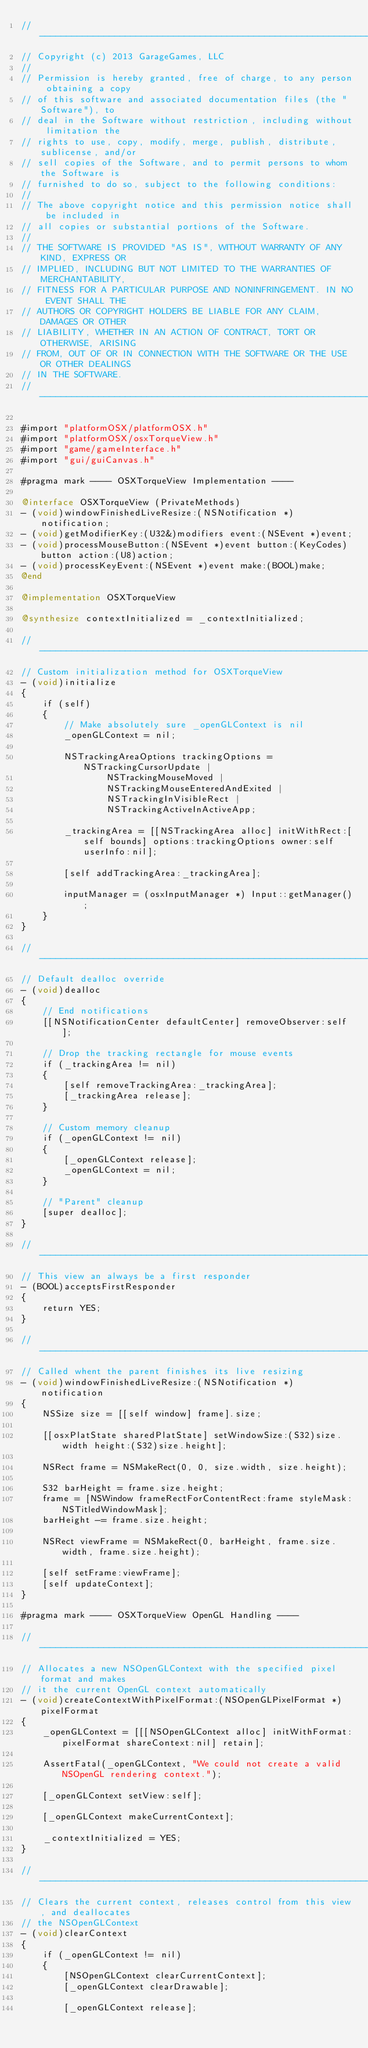Convert code to text. <code><loc_0><loc_0><loc_500><loc_500><_ObjectiveC_>//-----------------------------------------------------------------------------
// Copyright (c) 2013 GarageGames, LLC
//
// Permission is hereby granted, free of charge, to any person obtaining a copy
// of this software and associated documentation files (the "Software"), to
// deal in the Software without restriction, including without limitation the
// rights to use, copy, modify, merge, publish, distribute, sublicense, and/or
// sell copies of the Software, and to permit persons to whom the Software is
// furnished to do so, subject to the following conditions:
//
// The above copyright notice and this permission notice shall be included in
// all copies or substantial portions of the Software.
//
// THE SOFTWARE IS PROVIDED "AS IS", WITHOUT WARRANTY OF ANY KIND, EXPRESS OR
// IMPLIED, INCLUDING BUT NOT LIMITED TO THE WARRANTIES OF MERCHANTABILITY,
// FITNESS FOR A PARTICULAR PURPOSE AND NONINFRINGEMENT. IN NO EVENT SHALL THE
// AUTHORS OR COPYRIGHT HOLDERS BE LIABLE FOR ANY CLAIM, DAMAGES OR OTHER
// LIABILITY, WHETHER IN AN ACTION OF CONTRACT, TORT OR OTHERWISE, ARISING
// FROM, OUT OF OR IN CONNECTION WITH THE SOFTWARE OR THE USE OR OTHER DEALINGS
// IN THE SOFTWARE.
//-----------------------------------------------------------------------------

#import "platformOSX/platformOSX.h"
#import "platformOSX/osxTorqueView.h"
#import "game/gameInterface.h"
#import "gui/guiCanvas.h"

#pragma mark ---- OSXTorqueView Implementation ----

@interface OSXTorqueView (PrivateMethods)
- (void)windowFinishedLiveResize:(NSNotification *)notification;
- (void)getModifierKey:(U32&)modifiers event:(NSEvent *)event;
- (void)processMouseButton:(NSEvent *)event button:(KeyCodes)button action:(U8)action;
- (void)processKeyEvent:(NSEvent *)event make:(BOOL)make;
@end

@implementation OSXTorqueView

@synthesize contextInitialized = _contextInitialized;

//-----------------------------------------------------------------------------
// Custom initialization method for OSXTorqueView
- (void)initialize
{
    if (self)
    {
        // Make absolutely sure _openGLContext is nil
        _openGLContext = nil;

        NSTrackingAreaOptions trackingOptions = NSTrackingCursorUpdate |
                NSTrackingMouseMoved |
                NSTrackingMouseEnteredAndExited |
                NSTrackingInVisibleRect |
                NSTrackingActiveInActiveApp;

        _trackingArea = [[NSTrackingArea alloc] initWithRect:[self bounds] options:trackingOptions owner:self userInfo:nil];

        [self addTrackingArea:_trackingArea];

        inputManager = (osxInputManager *) Input::getManager();
    }
}

//-----------------------------------------------------------------------------
// Default dealloc override
- (void)dealloc
{
    // End notifications
    [[NSNotificationCenter defaultCenter] removeObserver:self];

    // Drop the tracking rectangle for mouse events
    if (_trackingArea != nil)
    {
        [self removeTrackingArea:_trackingArea];
        [_trackingArea release];
    }

    // Custom memory cleanup
    if (_openGLContext != nil)
    {
        [_openGLContext release];
        _openGLContext = nil;
    }

    // "Parent" cleanup
    [super dealloc];
}

//-----------------------------------------------------------------------------
// This view an always be a first responder
- (BOOL)acceptsFirstResponder
{
    return YES;
}

//-----------------------------------------------------------------------------
// Called whent the parent finishes its live resizing
- (void)windowFinishedLiveResize:(NSNotification *)notification
{
    NSSize size = [[self window] frame].size;

    [[osxPlatState sharedPlatState] setWindowSize:(S32)size.width height:(S32)size.height];
    
    NSRect frame = NSMakeRect(0, 0, size.width, size.height);
    
    S32 barHeight = frame.size.height;
    frame = [NSWindow frameRectForContentRect:frame styleMask:NSTitledWindowMask];
    barHeight -= frame.size.height;
    
    NSRect viewFrame = NSMakeRect(0, barHeight, frame.size.width, frame.size.height);
    
    [self setFrame:viewFrame];
    [self updateContext];
}

#pragma mark ---- OSXTorqueView OpenGL Handling ----

//-----------------------------------------------------------------------------
// Allocates a new NSOpenGLContext with the specified pixel format and makes
// it the current OpenGL context automatically
- (void)createContextWithPixelFormat:(NSOpenGLPixelFormat *)pixelFormat
{
    _openGLContext = [[[NSOpenGLContext alloc] initWithFormat:pixelFormat shareContext:nil] retain];

    AssertFatal(_openGLContext, "We could not create a valid NSOpenGL rendering context.");

    [_openGLContext setView:self];

    [_openGLContext makeCurrentContext];

    _contextInitialized = YES;
}

//-----------------------------------------------------------------------------
// Clears the current context, releases control from this view, and deallocates
// the NSOpenGLContext
- (void)clearContext
{
    if (_openGLContext != nil)
    {
        [NSOpenGLContext clearCurrentContext];
        [_openGLContext clearDrawable];

        [_openGLContext release];</code> 